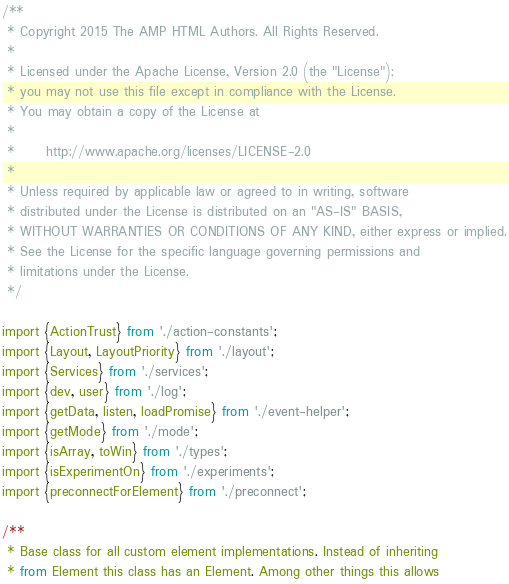Convert code to text. <code><loc_0><loc_0><loc_500><loc_500><_JavaScript_>/**
 * Copyright 2015 The AMP HTML Authors. All Rights Reserved.
 *
 * Licensed under the Apache License, Version 2.0 (the "License");
 * you may not use this file except in compliance with the License.
 * You may obtain a copy of the License at
 *
 *      http://www.apache.org/licenses/LICENSE-2.0
 *
 * Unless required by applicable law or agreed to in writing, software
 * distributed under the License is distributed on an "AS-IS" BASIS,
 * WITHOUT WARRANTIES OR CONDITIONS OF ANY KIND, either express or implied.
 * See the License for the specific language governing permissions and
 * limitations under the License.
 */

import {ActionTrust} from './action-constants';
import {Layout, LayoutPriority} from './layout';
import {Services} from './services';
import {dev, user} from './log';
import {getData, listen, loadPromise} from './event-helper';
import {getMode} from './mode';
import {isArray, toWin} from './types';
import {isExperimentOn} from './experiments';
import {preconnectForElement} from './preconnect';

/**
 * Base class for all custom element implementations. Instead of inheriting
 * from Element this class has an Element. Among other things this allows</code> 